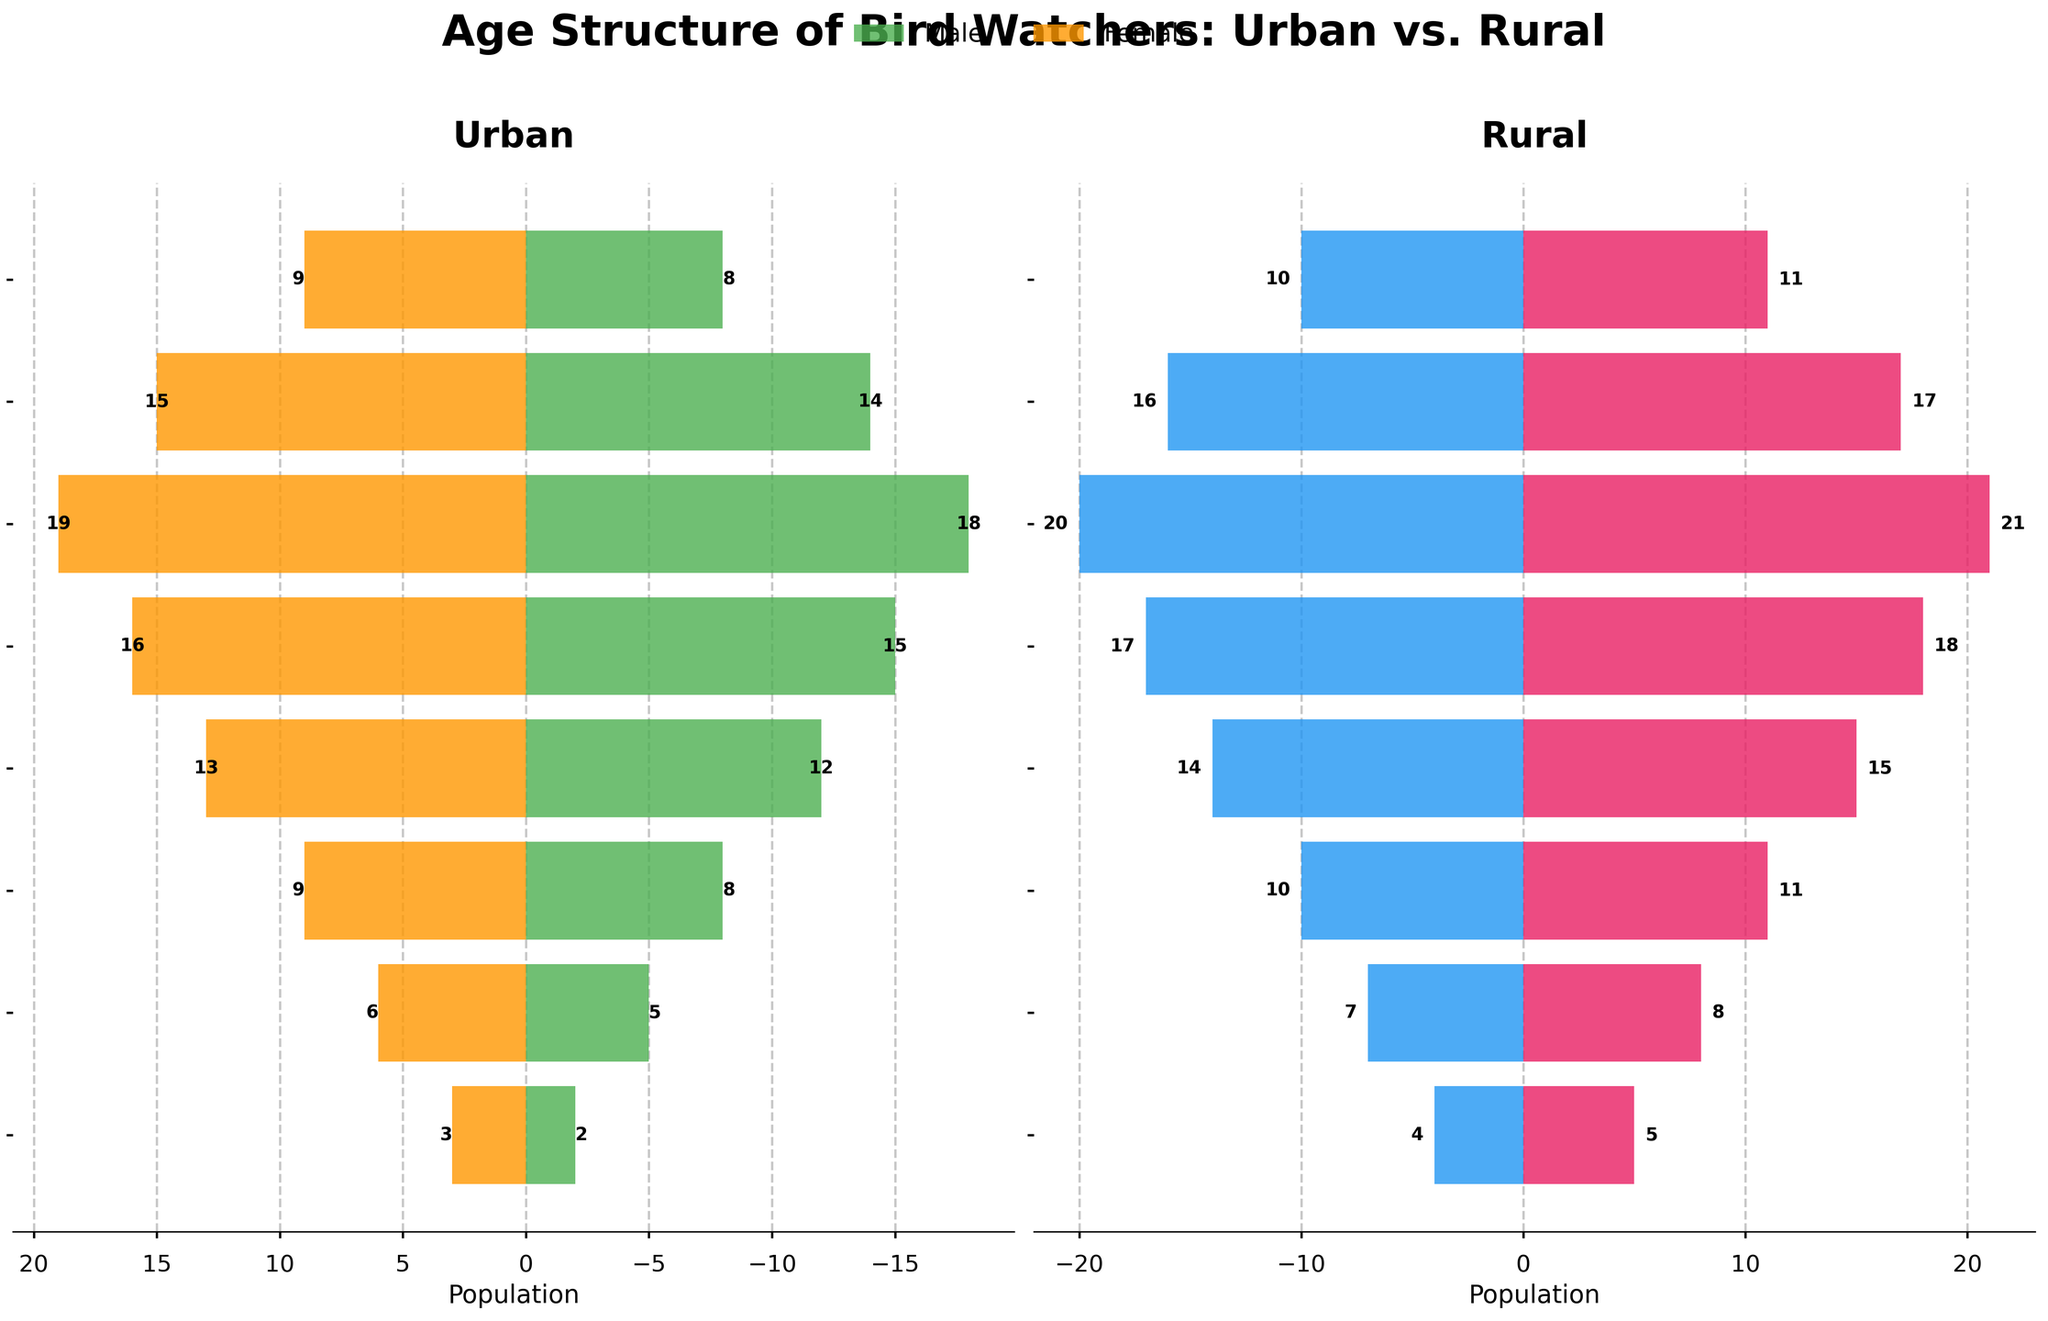What's the title of the figure? The title is usually found at the top of the figure. Here, it's clearly written at the top center of the plot.
Answer: Age Structure of Bird Watchers: Urban vs. Rural What are the age groups listed on the y-axis? The age groups are listed on the y-axis, which are visible labels on the left side of the figure. The age groups include 0-14, 15-24, 25-34, 35-44, 45-54, 55-64, 65-74, and 75+.
Answer: 0-14, 15-24, 25-34, 35-44, 45-54, 55-64, 65-74, 75+ Comparing urban and rural areas, which male age group has the highest population? By examining the lengths of the bars on the left side of each subplot for males, the age group with the highest population can be identified. In both urban and rural areas, the 55-64 age group has the highest population.
Answer: 55-64 Which age group has the smallest difference in total population between urban and rural areas? To find the smallest difference, calculate the total population for each age group in both areas and then find the absolute differences. The 0-14 age group has the smallest difference; urban: 5, rural: 9, difference: 4.
Answer: 0-14 How many total female bird watchers are in the rural area? Add up all the female populations for each age group in the rural section of the plot on the right. 5 + 8 + 11 + 15 + 18 + 21 + 17 + 11 = 106.
Answer: 106 Which group has a higher total population of bird watchers: urban or rural? Sum the populations of all groups (both male and female) for urban and rural sections. Urban's total is 2+3+5+6+8+9+12+13+15+16+18+19+14+15+8+9 = 172, and Rural's total is 4+5+7+8+10+11+14+15+17+18+20+21+16+17+10+11 = 193.
Answer: Rural Which age group shows a higher female population in urban areas compared to rural areas? Compare the length of the bars representing the female population for each age group in urban and rural sections. The 75+ age group has higher female population in urban (9) compared to rural (11).
Answer: 75+ What is the ratio of urban male to urban female bird watchers in the 45-54 age group? The urban male population is 15, and the urban female population is 16 for the 45-54 age group. The ratio is 15:16.
Answer: 15:16 How does the male population of 35-44 age group in urban areas compare to the same group's female population in rural areas? Look at the length of the urban male bar in the 35-44 age group and compare it to the rural female bar of the same age group. Urban male: 12, Rural female: 15. The male population is smaller.
Answer: Smaller Which gender tends to have a higher population in the 65-74 age group in both urban and rural areas? Compare the length of the bars for males and females in the 65-74 age group within both subplots. In both urban and rural areas, females have a higher population (15 and 17) compared to males (14 and 16).
Answer: Female 